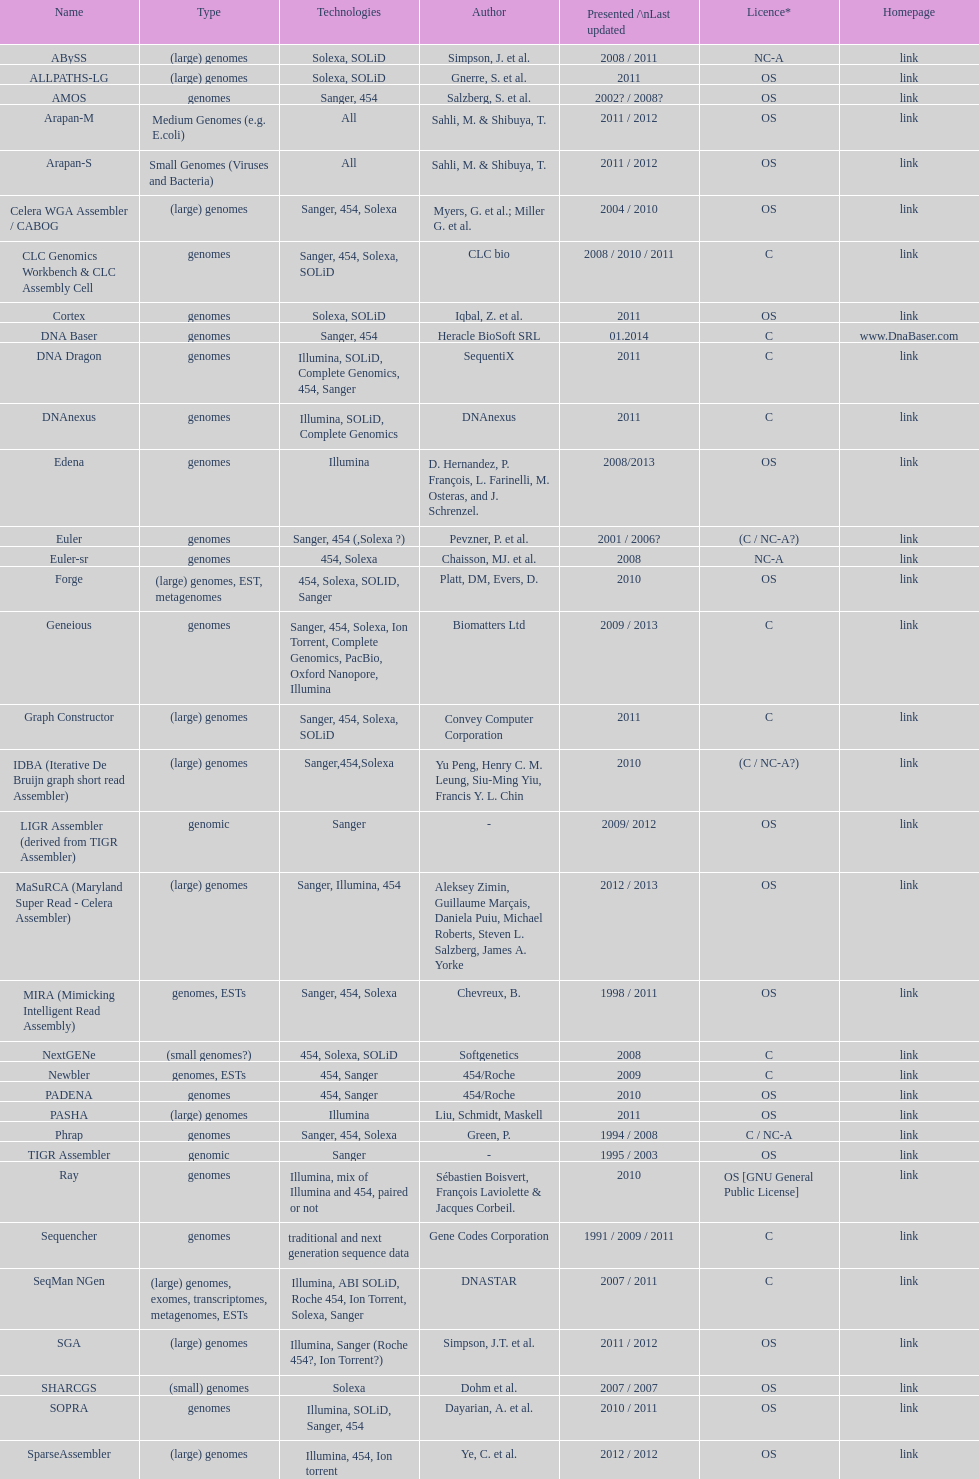What was the overall count of sahi, m. & shilbuya, t. appearing as co-authors? 2. 